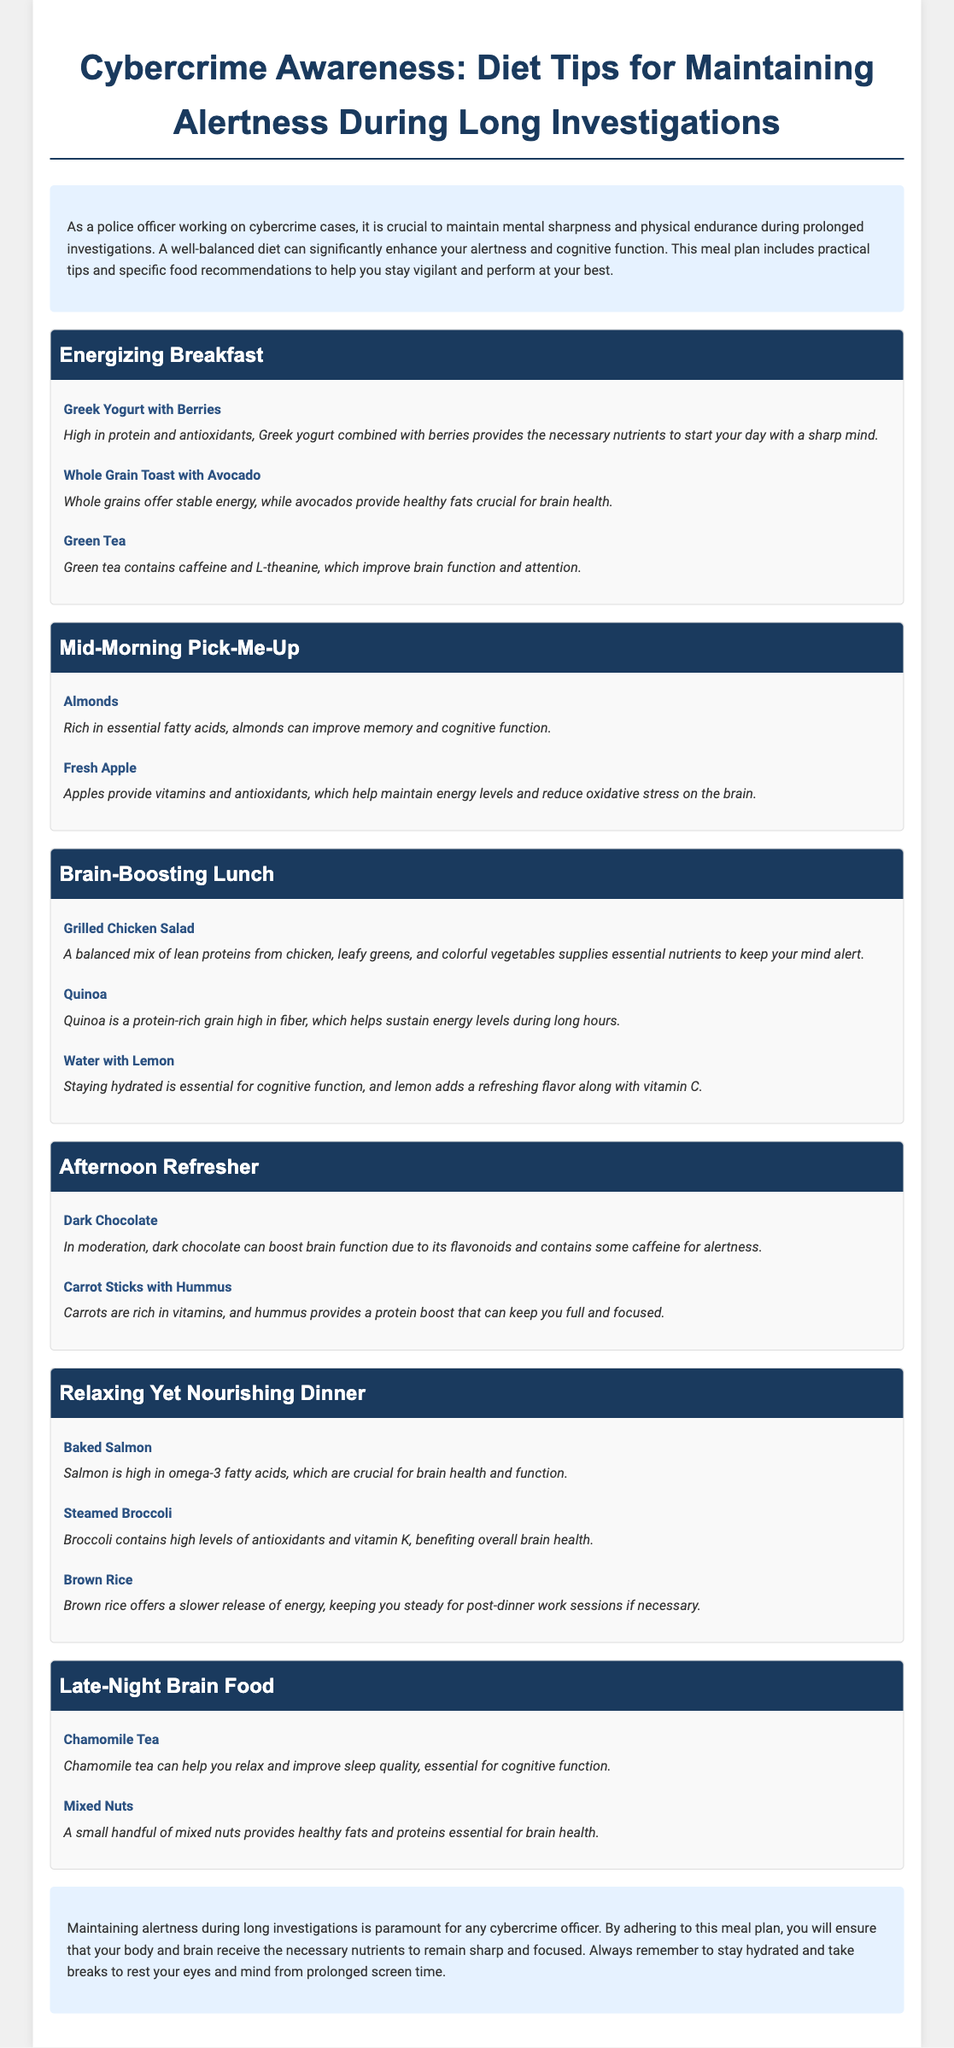What is the title of the meal plan? The title is found at the top of the document and summarizes the content of the meal plan related to cybercrime awareness.
Answer: Cybercrime Awareness: Diet Tips for Maintaining Alertness During Long Investigations What is included in the energizing breakfast? This information can be found in the section that details breakfast options, highlighting the recommended meals.
Answer: Greek Yogurt with Berries, Whole Grain Toast with Avocado, Green Tea Which food is recommended for a mid-morning pick-me-up? This is mentioned in the mid-morning section of the meal plan, listing healthy snacks.
Answer: Almonds What is a brain-boosting lunch option? This question refers to the lunch section where a specific meal is suggested for cognitive enhancement.
Answer: Grilled Chicken Salad How many meal sections are in the document? The structure of the document reveals distinct sections dedicated to each meal of the day.
Answer: Six What does the document suggest for a relaxing yet nourishing dinner? This question addresses the dinner section for specific meal recommendations.
Answer: Baked Salmon, Steamed Broccoli, Brown Rice Which beverage is recommended for late-night brain food? The late-night section specifies drinks that support cognitive function and relaxation.
Answer: Chamomile Tea Why is hydration emphasized in the conclusion? The conclusion discusses the importance of hydration for maintaining cognitive function during investigations.
Answer: Essential for cognitive function What type of dietary advice does the meal plan provide? This refers to the overall purpose of the document, which guides dietary choices for police officers.
Answer: Maintaining alertness 